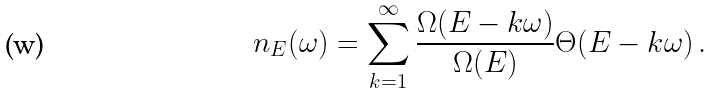<formula> <loc_0><loc_0><loc_500><loc_500>n _ { E } ( \omega ) = \sum _ { k = 1 } ^ { \infty } \frac { \Omega ( E - k \omega ) } { \Omega ( E ) } \Theta ( E - k \omega ) \, .</formula> 